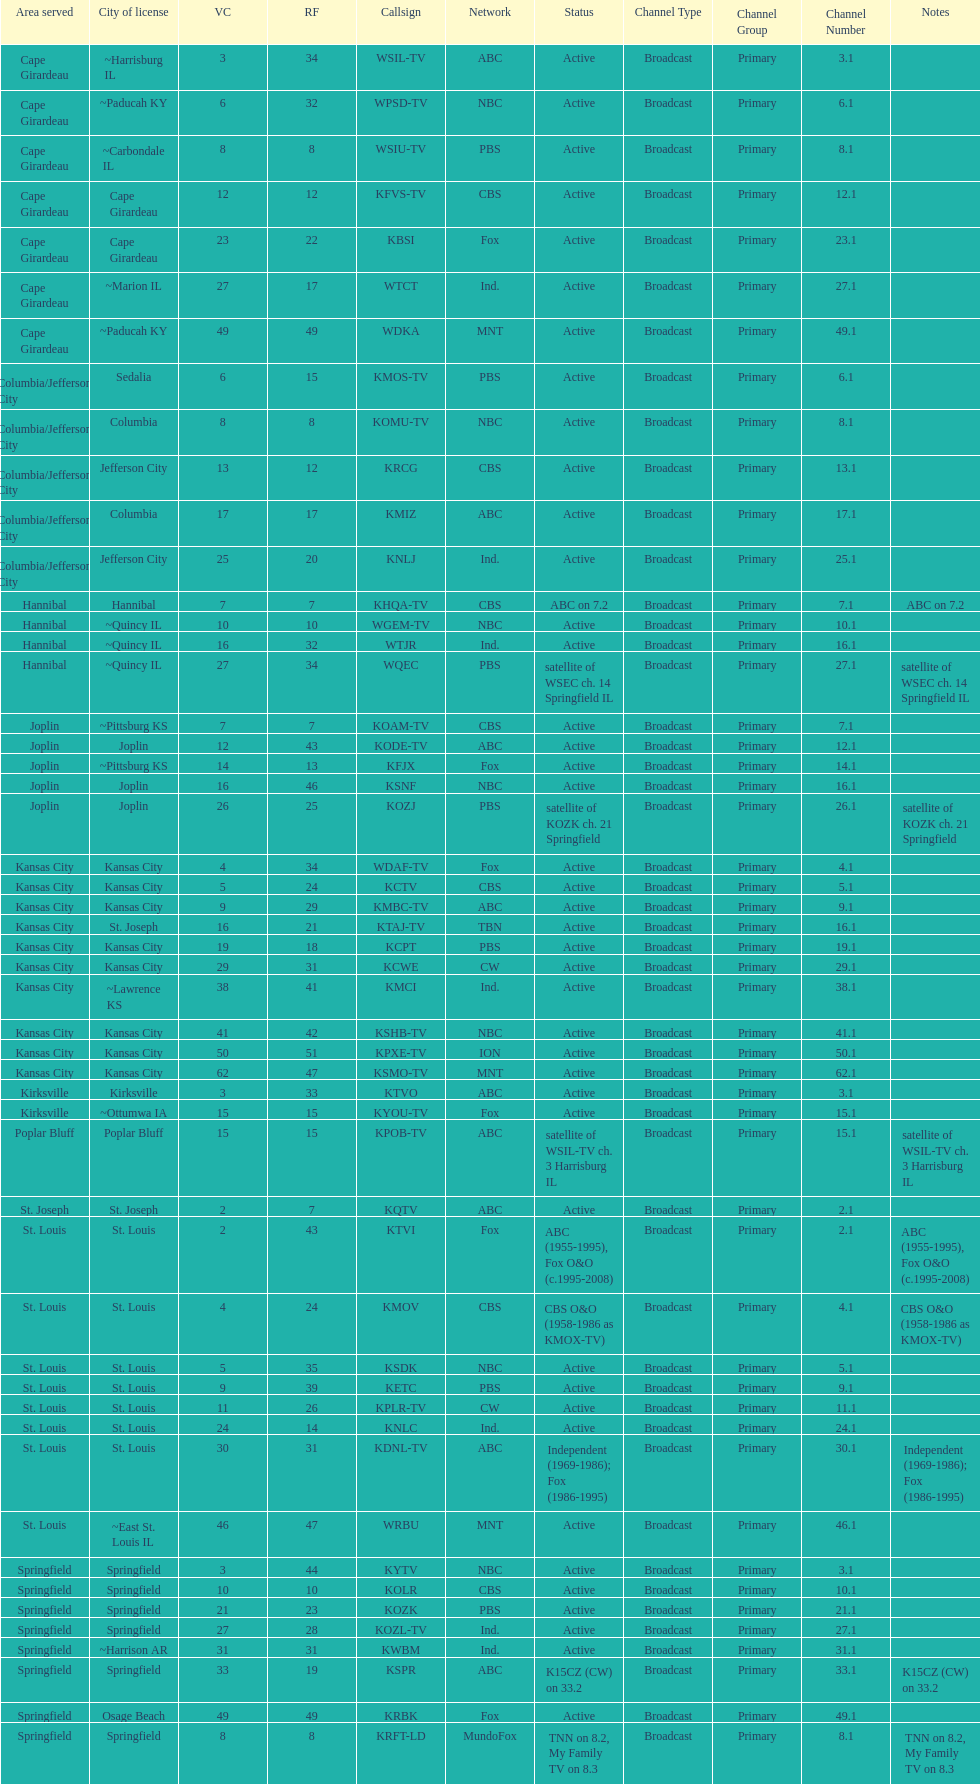How many television stations serve the cape girardeau area? 7. Can you parse all the data within this table? {'header': ['Area served', 'City of license', 'VC', 'RF', 'Callsign', 'Network', 'Status', 'Channel Type', 'Channel Group', 'Channel Number', 'Notes'], 'rows': [['Cape Girardeau', '~Harrisburg IL', '3', '34', 'WSIL-TV', 'ABC', 'Active', 'Broadcast', 'Primary', '3.1', ''], ['Cape Girardeau', '~Paducah KY', '6', '32', 'WPSD-TV', 'NBC', 'Active', 'Broadcast', 'Primary', '6.1', ''], ['Cape Girardeau', '~Carbondale IL', '8', '8', 'WSIU-TV', 'PBS', 'Active', 'Broadcast', 'Primary', '8.1', ''], ['Cape Girardeau', 'Cape Girardeau', '12', '12', 'KFVS-TV', 'CBS', 'Active', 'Broadcast', 'Primary', '12.1', ''], ['Cape Girardeau', 'Cape Girardeau', '23', '22', 'KBSI', 'Fox', 'Active', 'Broadcast', 'Primary', '23.1', ''], ['Cape Girardeau', '~Marion IL', '27', '17', 'WTCT', 'Ind.', 'Active', 'Broadcast', 'Primary', '27.1', ''], ['Cape Girardeau', '~Paducah KY', '49', '49', 'WDKA', 'MNT', 'Active', 'Broadcast', 'Primary', '49.1', ''], ['Columbia/Jefferson City', 'Sedalia', '6', '15', 'KMOS-TV', 'PBS', 'Active', 'Broadcast', 'Primary', '6.1', ''], ['Columbia/Jefferson City', 'Columbia', '8', '8', 'KOMU-TV', 'NBC', 'Active', 'Broadcast', 'Primary', '8.1', ''], ['Columbia/Jefferson City', 'Jefferson City', '13', '12', 'KRCG', 'CBS', 'Active', 'Broadcast', 'Primary', '13.1', ''], ['Columbia/Jefferson City', 'Columbia', '17', '17', 'KMIZ', 'ABC', 'Active', 'Broadcast', 'Primary', '17.1', ''], ['Columbia/Jefferson City', 'Jefferson City', '25', '20', 'KNLJ', 'Ind.', 'Active', 'Broadcast', 'Primary', '25.1', ''], ['Hannibal', 'Hannibal', '7', '7', 'KHQA-TV', 'CBS', 'ABC on 7.2', 'Broadcast', 'Primary', '7.1', 'ABC on 7.2'], ['Hannibal', '~Quincy IL', '10', '10', 'WGEM-TV', 'NBC', 'Active', 'Broadcast', 'Primary', '10.1', ''], ['Hannibal', '~Quincy IL', '16', '32', 'WTJR', 'Ind.', 'Active', 'Broadcast', 'Primary', '16.1', ''], ['Hannibal', '~Quincy IL', '27', '34', 'WQEC', 'PBS', 'satellite of WSEC ch. 14 Springfield IL', 'Broadcast', 'Primary', '27.1', 'satellite of WSEC ch. 14 Springfield IL'], ['Joplin', '~Pittsburg KS', '7', '7', 'KOAM-TV', 'CBS', 'Active', 'Broadcast', 'Primary', '7.1', ''], ['Joplin', 'Joplin', '12', '43', 'KODE-TV', 'ABC', 'Active', 'Broadcast', 'Primary', '12.1', ''], ['Joplin', '~Pittsburg KS', '14', '13', 'KFJX', 'Fox', 'Active', 'Broadcast', 'Primary', '14.1', ''], ['Joplin', 'Joplin', '16', '46', 'KSNF', 'NBC', 'Active', 'Broadcast', 'Primary', '16.1', ''], ['Joplin', 'Joplin', '26', '25', 'KOZJ', 'PBS', 'satellite of KOZK ch. 21 Springfield', 'Broadcast', 'Primary', '26.1', 'satellite of KOZK ch. 21 Springfield'], ['Kansas City', 'Kansas City', '4', '34', 'WDAF-TV', 'Fox', 'Active', 'Broadcast', 'Primary', '4.1', ''], ['Kansas City', 'Kansas City', '5', '24', 'KCTV', 'CBS', 'Active', 'Broadcast', 'Primary', '5.1', ''], ['Kansas City', 'Kansas City', '9', '29', 'KMBC-TV', 'ABC', 'Active', 'Broadcast', 'Primary', '9.1', ''], ['Kansas City', 'St. Joseph', '16', '21', 'KTAJ-TV', 'TBN', 'Active', 'Broadcast', 'Primary', '16.1', ''], ['Kansas City', 'Kansas City', '19', '18', 'KCPT', 'PBS', 'Active', 'Broadcast', 'Primary', '19.1', ''], ['Kansas City', 'Kansas City', '29', '31', 'KCWE', 'CW', 'Active', 'Broadcast', 'Primary', '29.1', ''], ['Kansas City', '~Lawrence KS', '38', '41', 'KMCI', 'Ind.', 'Active', 'Broadcast', 'Primary', '38.1', ''], ['Kansas City', 'Kansas City', '41', '42', 'KSHB-TV', 'NBC', 'Active', 'Broadcast', 'Primary', '41.1', ''], ['Kansas City', 'Kansas City', '50', '51', 'KPXE-TV', 'ION', 'Active', 'Broadcast', 'Primary', '50.1', ''], ['Kansas City', 'Kansas City', '62', '47', 'KSMO-TV', 'MNT', 'Active', 'Broadcast', 'Primary', '62.1', ''], ['Kirksville', 'Kirksville', '3', '33', 'KTVO', 'ABC', 'Active', 'Broadcast', 'Primary', '3.1', ''], ['Kirksville', '~Ottumwa IA', '15', '15', 'KYOU-TV', 'Fox', 'Active', 'Broadcast', 'Primary', '15.1', ''], ['Poplar Bluff', 'Poplar Bluff', '15', '15', 'KPOB-TV', 'ABC', 'satellite of WSIL-TV ch. 3 Harrisburg IL', 'Broadcast', 'Primary', '15.1', 'satellite of WSIL-TV ch. 3 Harrisburg IL'], ['St. Joseph', 'St. Joseph', '2', '7', 'KQTV', 'ABC', 'Active', 'Broadcast', 'Primary', '2.1', ''], ['St. Louis', 'St. Louis', '2', '43', 'KTVI', 'Fox', 'ABC (1955-1995), Fox O&O (c.1995-2008)', 'Broadcast', 'Primary', '2.1', 'ABC (1955-1995), Fox O&O (c.1995-2008)'], ['St. Louis', 'St. Louis', '4', '24', 'KMOV', 'CBS', 'CBS O&O (1958-1986 as KMOX-TV)', 'Broadcast', 'Primary', '4.1', 'CBS O&O (1958-1986 as KMOX-TV)'], ['St. Louis', 'St. Louis', '5', '35', 'KSDK', 'NBC', 'Active', 'Broadcast', 'Primary', '5.1', ''], ['St. Louis', 'St. Louis', '9', '39', 'KETC', 'PBS', 'Active', 'Broadcast', 'Primary', '9.1', ''], ['St. Louis', 'St. Louis', '11', '26', 'KPLR-TV', 'CW', 'Active', 'Broadcast', 'Primary', '11.1', ''], ['St. Louis', 'St. Louis', '24', '14', 'KNLC', 'Ind.', 'Active', 'Broadcast', 'Primary', '24.1', ''], ['St. Louis', 'St. Louis', '30', '31', 'KDNL-TV', 'ABC', 'Independent (1969-1986); Fox (1986-1995)', 'Broadcast', 'Primary', '30.1', 'Independent (1969-1986); Fox (1986-1995)'], ['St. Louis', '~East St. Louis IL', '46', '47', 'WRBU', 'MNT', 'Active', 'Broadcast', 'Primary', '46.1', ''], ['Springfield', 'Springfield', '3', '44', 'KYTV', 'NBC', 'Active', 'Broadcast', 'Primary', '3.1', ''], ['Springfield', 'Springfield', '10', '10', 'KOLR', 'CBS', 'Active', 'Broadcast', 'Primary', '10.1', ''], ['Springfield', 'Springfield', '21', '23', 'KOZK', 'PBS', 'Active', 'Broadcast', 'Primary', '21.1', ''], ['Springfield', 'Springfield', '27', '28', 'KOZL-TV', 'Ind.', 'Active', 'Broadcast', 'Primary', '27.1', ''], ['Springfield', '~Harrison AR', '31', '31', 'KWBM', 'Ind.', 'Active', 'Broadcast', 'Primary', '31.1', ''], ['Springfield', 'Springfield', '33', '19', 'KSPR', 'ABC', 'K15CZ (CW) on 33.2', 'Broadcast', 'Primary', '33.1', 'K15CZ (CW) on 33.2'], ['Springfield', 'Osage Beach', '49', '49', 'KRBK', 'Fox', 'Active', 'Broadcast', 'Primary', '49.1', ''], ['Springfield', 'Springfield', '8', '8', 'KRFT-LD', 'MundoFox', 'TNN on 8.2, My Family TV on 8.3', 'Broadcast', 'Primary', '8.1', 'TNN on 8.2, My Family TV on 8.3']]} 